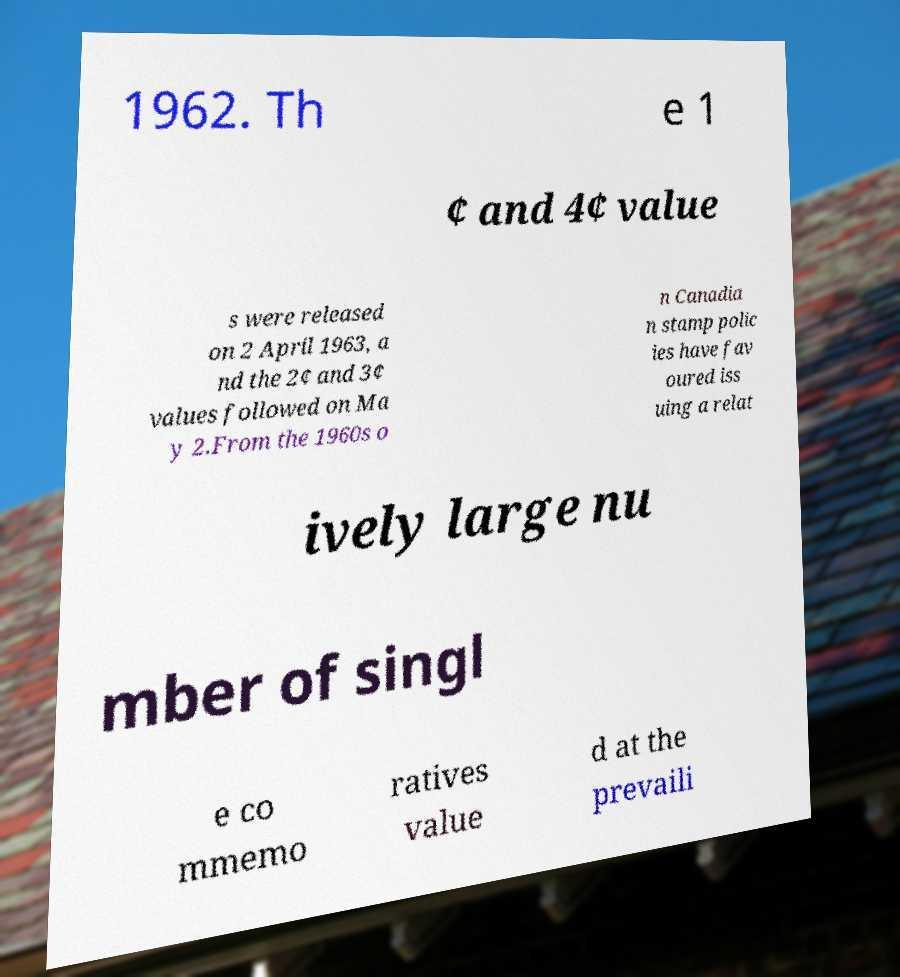For documentation purposes, I need the text within this image transcribed. Could you provide that? 1962. Th e 1 ¢ and 4¢ value s were released on 2 April 1963, a nd the 2¢ and 3¢ values followed on Ma y 2.From the 1960s o n Canadia n stamp polic ies have fav oured iss uing a relat ively large nu mber of singl e co mmemo ratives value d at the prevaili 